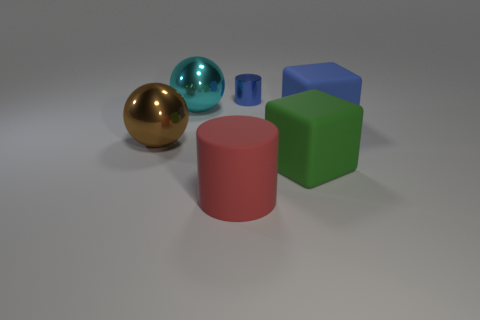Add 4 big metal objects. How many objects exist? 10 Subtract all spheres. How many objects are left? 4 Add 5 red matte objects. How many red matte objects exist? 6 Subtract 1 blue cylinders. How many objects are left? 5 Subtract all tiny gray metal blocks. Subtract all big blue matte blocks. How many objects are left? 5 Add 1 red things. How many red things are left? 2 